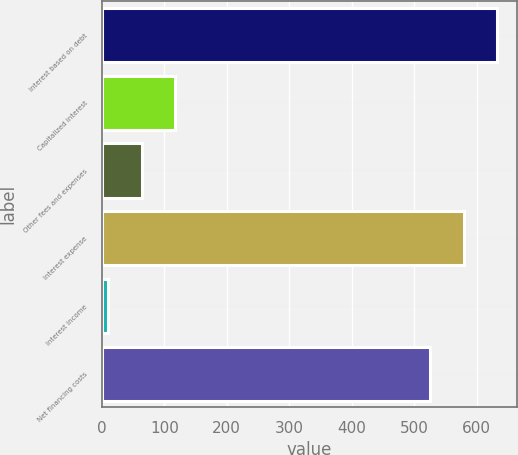<chart> <loc_0><loc_0><loc_500><loc_500><bar_chart><fcel>Interest based on debt<fcel>Capitalized interest<fcel>Other fees and expenses<fcel>Interest expense<fcel>Interest income<fcel>Net financing costs<nl><fcel>633.2<fcel>117.2<fcel>63.6<fcel>579.6<fcel>10<fcel>526<nl></chart> 